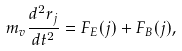<formula> <loc_0><loc_0><loc_500><loc_500>m _ { v } \frac { d ^ { 2 } { r } _ { j } } { d t ^ { 2 } } = { F } _ { E } ( j ) + { F } _ { B } ( j ) ,</formula> 